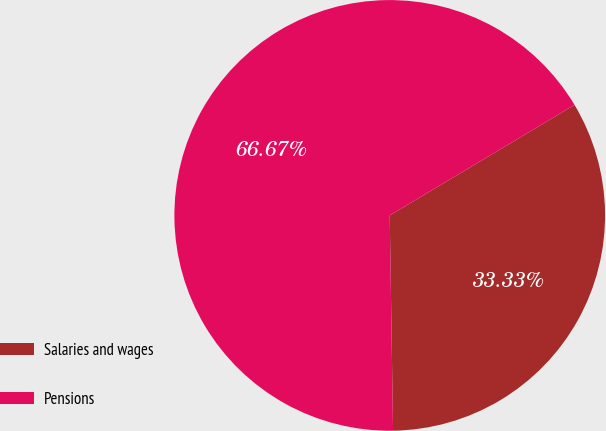<chart> <loc_0><loc_0><loc_500><loc_500><pie_chart><fcel>Salaries and wages<fcel>Pensions<nl><fcel>33.33%<fcel>66.67%<nl></chart> 